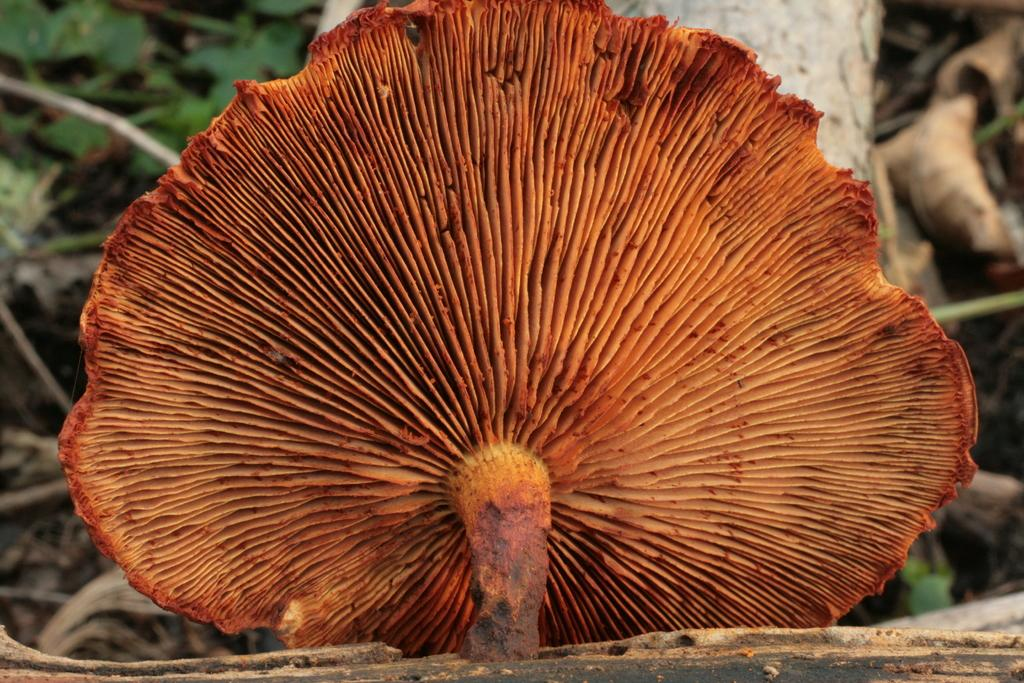What is the main subject of the image? The main subject of the image is a mushroom. Can you describe the color of the mushroom? The mushroom is brownish in color. What surface does the mushroom appear to be on? The mushroom appears to be on wood. What can be seen in the background of the image? There are leaves visible in the background of the image. What type of mouth can be seen on the mushroom in the image? There is no mouth present on the mushroom in the image, as mushrooms do not have mouths. 